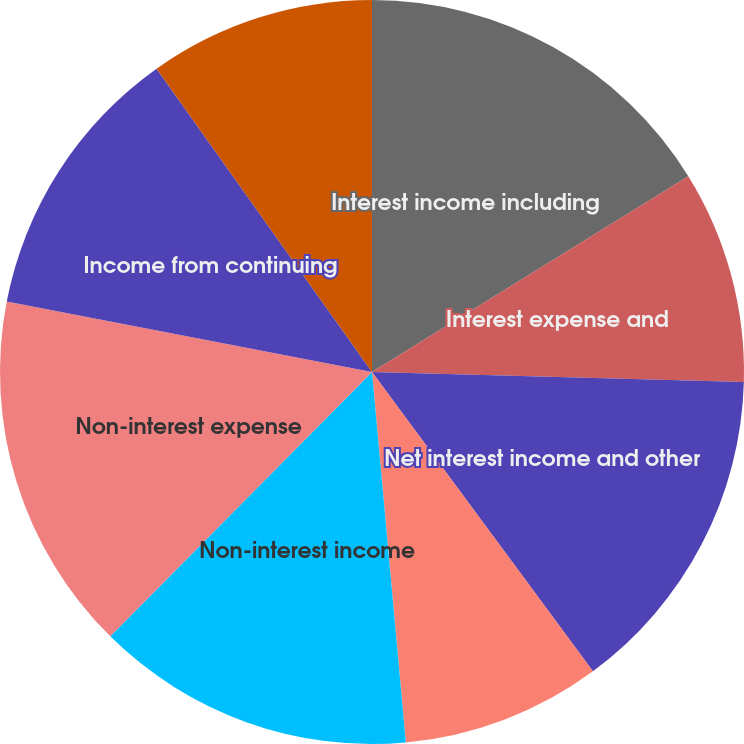Convert chart to OTSL. <chart><loc_0><loc_0><loc_500><loc_500><pie_chart><fcel>Interest income including<fcel>Interest expense and<fcel>Net interest income and other<fcel>Provision for loan losses<fcel>Non-interest income<fcel>Non-interest expense<fcel>Income from continuing<fcel>Income tax expense<nl><fcel>16.18%<fcel>9.25%<fcel>14.45%<fcel>8.67%<fcel>13.87%<fcel>15.61%<fcel>12.14%<fcel>9.83%<nl></chart> 